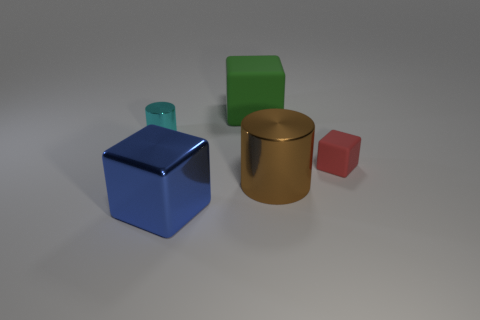Subtract all cubes. How many objects are left? 2 Subtract 1 blocks. How many blocks are left? 2 Subtract all yellow cylinders. Subtract all red blocks. How many cylinders are left? 2 Subtract all cyan spheres. How many green cylinders are left? 0 Subtract all big brown rubber blocks. Subtract all cyan cylinders. How many objects are left? 4 Add 5 large shiny things. How many large shiny things are left? 7 Add 3 small blue matte blocks. How many small blue matte blocks exist? 3 Add 3 small red spheres. How many objects exist? 8 Subtract all cyan cylinders. How many cylinders are left? 1 Subtract all red cubes. How many cubes are left? 2 